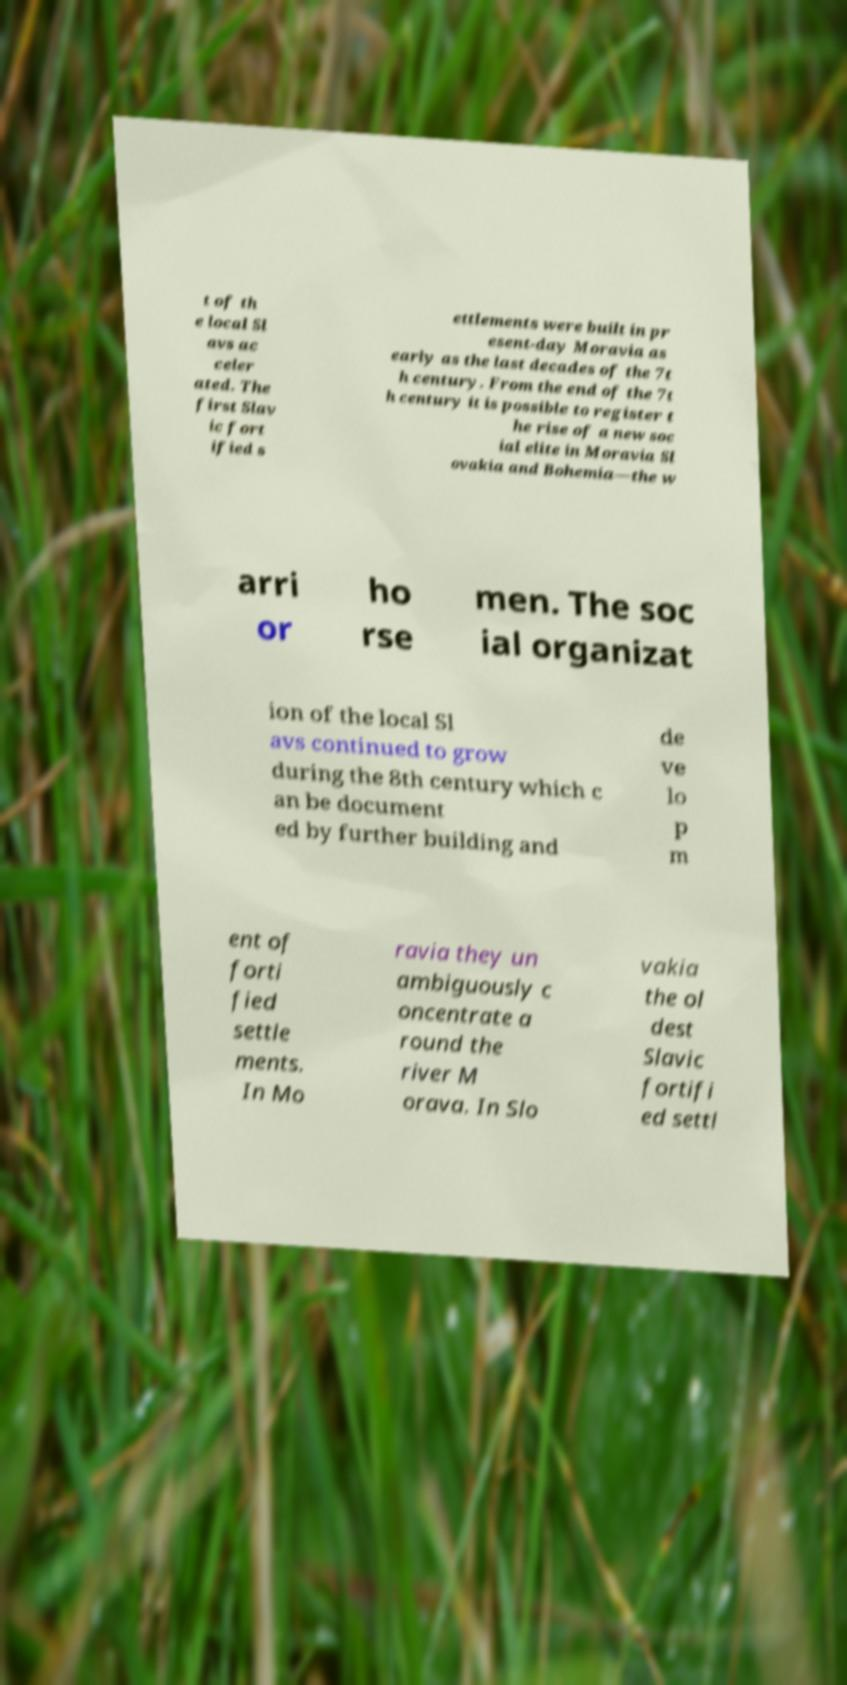I need the written content from this picture converted into text. Can you do that? t of th e local Sl avs ac celer ated. The first Slav ic fort ified s ettlements were built in pr esent-day Moravia as early as the last decades of the 7t h century. From the end of the 7t h century it is possible to register t he rise of a new soc ial elite in Moravia Sl ovakia and Bohemia—the w arri or ho rse men. The soc ial organizat ion of the local Sl avs continued to grow during the 8th century which c an be document ed by further building and de ve lo p m ent of forti fied settle ments. In Mo ravia they un ambiguously c oncentrate a round the river M orava. In Slo vakia the ol dest Slavic fortifi ed settl 